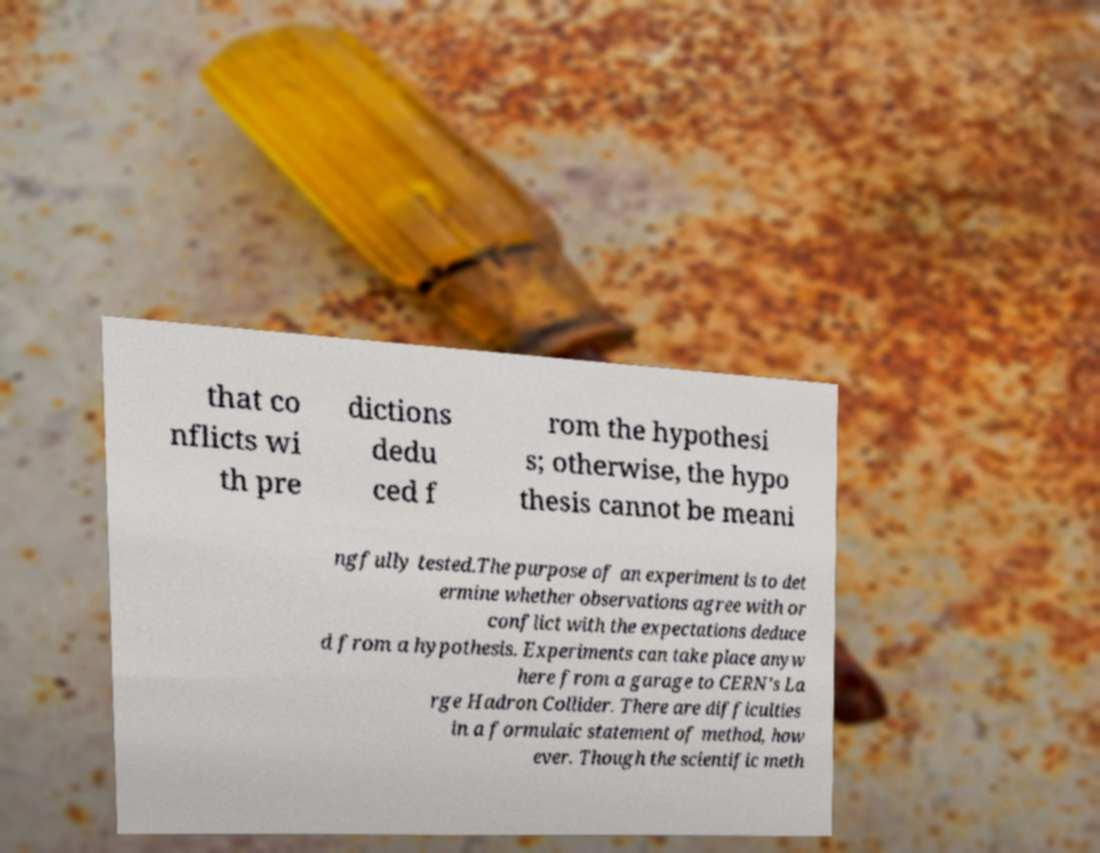Please read and relay the text visible in this image. What does it say? that co nflicts wi th pre dictions dedu ced f rom the hypothesi s; otherwise, the hypo thesis cannot be meani ngfully tested.The purpose of an experiment is to det ermine whether observations agree with or conflict with the expectations deduce d from a hypothesis. Experiments can take place anyw here from a garage to CERN's La rge Hadron Collider. There are difficulties in a formulaic statement of method, how ever. Though the scientific meth 